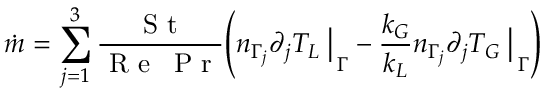<formula> <loc_0><loc_0><loc_500><loc_500>\dot { m } = \sum _ { j = 1 } ^ { 3 } \frac { S t } { R e \, P r } \left ( { n _ { \Gamma _ { j } } \partial _ { j } T _ { L } \, \left | } _ { \, \Gamma } - \frac { k _ { G } } { k _ { L } } { n _ { \Gamma _ { j } } \partial _ { j } T _ { G } \, \right | } _ { \, \Gamma } \right )</formula> 